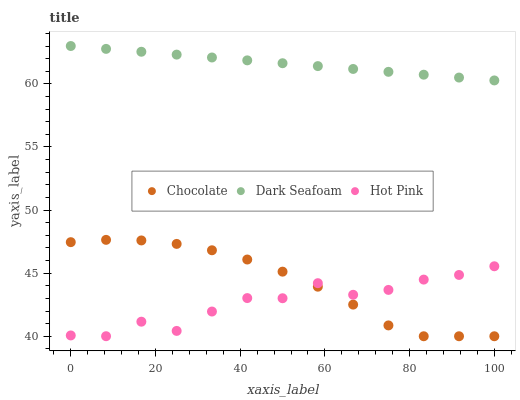Does Hot Pink have the minimum area under the curve?
Answer yes or no. Yes. Does Dark Seafoam have the maximum area under the curve?
Answer yes or no. Yes. Does Chocolate have the minimum area under the curve?
Answer yes or no. No. Does Chocolate have the maximum area under the curve?
Answer yes or no. No. Is Dark Seafoam the smoothest?
Answer yes or no. Yes. Is Hot Pink the roughest?
Answer yes or no. Yes. Is Chocolate the smoothest?
Answer yes or no. No. Is Chocolate the roughest?
Answer yes or no. No. Does Chocolate have the lowest value?
Answer yes or no. Yes. Does Hot Pink have the lowest value?
Answer yes or no. No. Does Dark Seafoam have the highest value?
Answer yes or no. Yes. Does Chocolate have the highest value?
Answer yes or no. No. Is Hot Pink less than Dark Seafoam?
Answer yes or no. Yes. Is Dark Seafoam greater than Hot Pink?
Answer yes or no. Yes. Does Chocolate intersect Hot Pink?
Answer yes or no. Yes. Is Chocolate less than Hot Pink?
Answer yes or no. No. Is Chocolate greater than Hot Pink?
Answer yes or no. No. Does Hot Pink intersect Dark Seafoam?
Answer yes or no. No. 